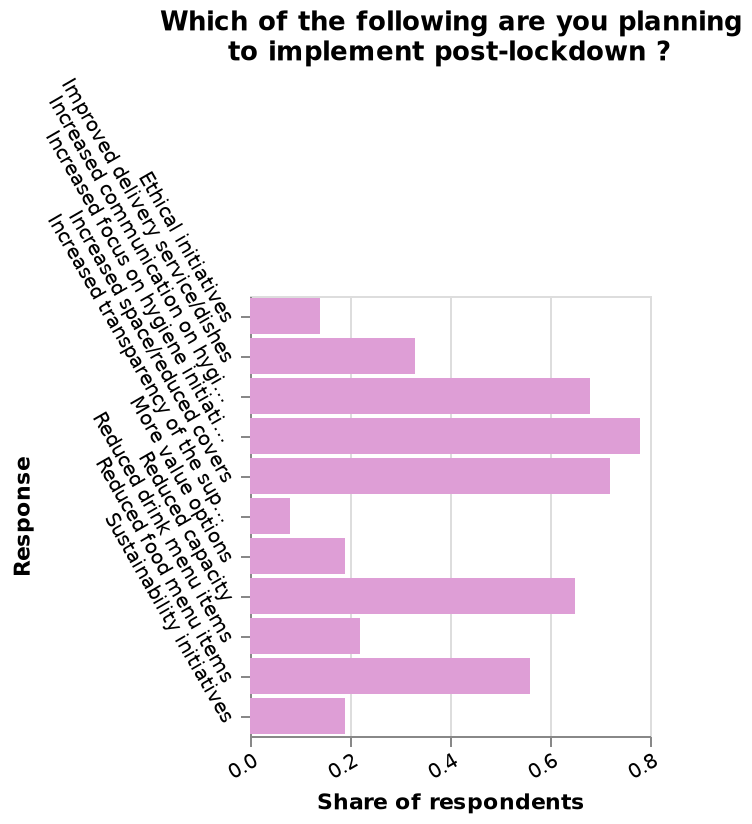<image>
How many people are intending to increase their hygiene habits?  The exact number of people is not mentioned in the given description. Are more people intending to increase their hygiene habits?  Yes, more people are intending to increase their hygiene habits. 